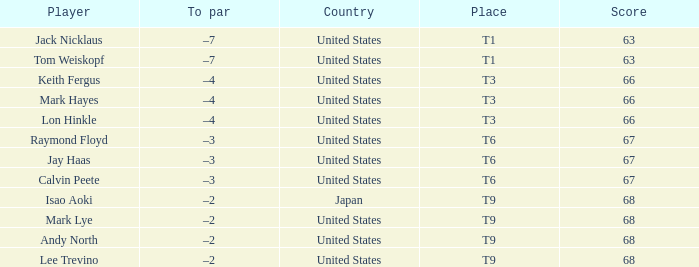What is the Country, when Place is T6, and when Player is "Raymond Floyd"? United States. 